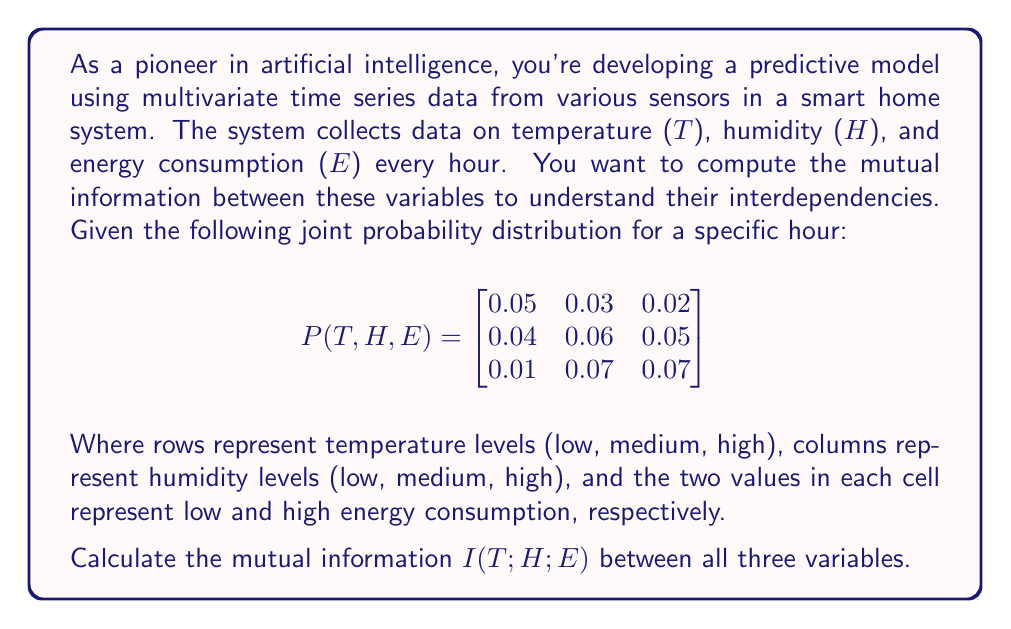Solve this math problem. To calculate the mutual information between three variables, we'll use the following formula:

$$I(T;H;E) = I(T;H) - I(T;H|E)$$

Where $I(T;H)$ is the mutual information between temperature and humidity, and $I(T;H|E)$ is the conditional mutual information between temperature and humidity given energy consumption.

Step 1: Calculate marginal probabilities

$P(T)$:
Low: 0.05 + 0.03 + 0.02 + 0.04 + 0.06 + 0.05 = 0.25
Medium: 0.04 + 0.06 + 0.05 + 0.01 + 0.07 + 0.07 = 0.30
High: 0.01 + 0.07 + 0.07 = 0.15

$P(H)$:
Low: 0.05 + 0.04 + 0.01 + 0.03 + 0.06 + 0.07 = 0.26
Medium: 0.03 + 0.06 + 0.07 = 0.16
High: 0.02 + 0.05 + 0.07 + 0.05 + 0.07 + 0.07 = 0.33

$P(E)$:
Low: 0.05 + 0.04 + 0.01 + 0.03 + 0.06 + 0.07 = 0.26
High: 0.03 + 0.06 + 0.07 + 0.02 + 0.05 + 0.07 = 0.30

Step 2: Calculate $I(T;H)$

$$I(T;H) = \sum_{t}\sum_{h} P(t,h) \log \frac{P(t,h)}{P(t)P(h)}$$

$I(T;H) = 0.08 \log \frac{0.08}{0.25 \cdot 0.26} + 0.09 \log \frac{0.09}{0.25 \cdot 0.16} + ... = 0.0397$ bits

Step 3: Calculate $I(T;H|E)$

$$I(T;H|E) = \sum_{e} P(e) \sum_{t}\sum_{h} P(t,h|e) \log \frac{P(t,h|e)}{P(t|e)P(h|e)}$$

For $E = low$:
$I(T;H|E=low) = 0.0294$ bits

For $E = high$:
$I(T;H|E=high) = 0.0215$ bits

$I(T;H|E) = 0.26 \cdot 0.0294 + 0.30 \cdot 0.0215 = 0.0141$ bits

Step 4: Calculate $I(T;H;E)$

$$I(T;H;E) = I(T;H) - I(T;H|E) = 0.0397 - 0.0141 = 0.0256$$ bits
Answer: The mutual information $I(T;H;E)$ between temperature, humidity, and energy consumption is approximately 0.0256 bits. 